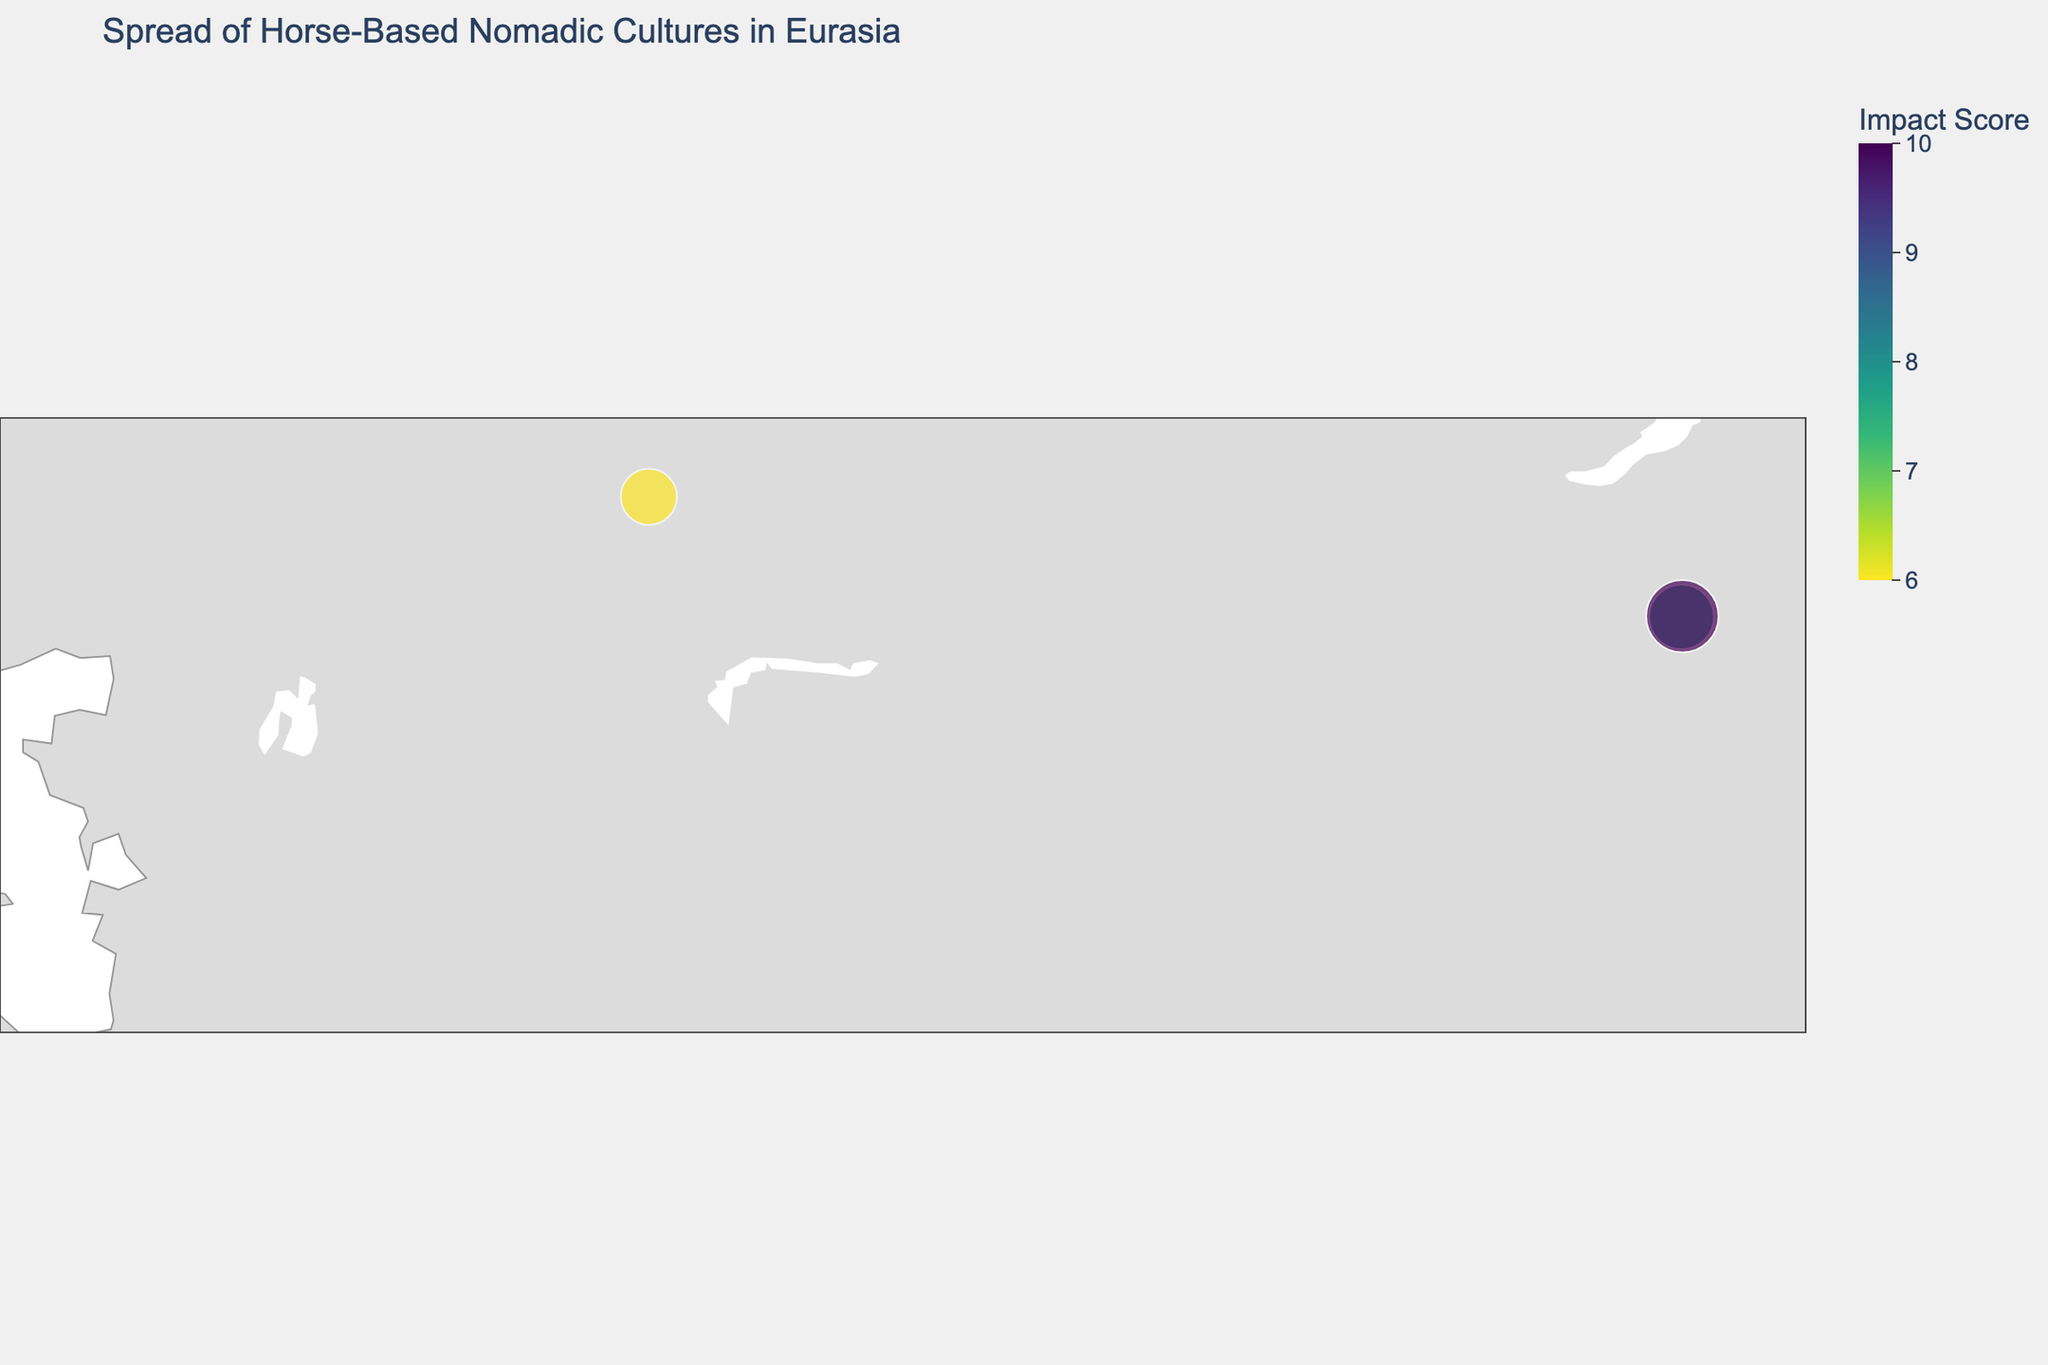Is the plot centered around a specific geographic area? If so, which area? The plot is centered on the Eurasian continent, specifically around the region encompassing the latitude of 45 and longitude of 80. This central positioning ensures that the majority of the horse-based nomadic cultures are appropriately plotted.
Answer: Eurasian continent What is the culture with the highest impact score? Identify the culture with the largest size marker on the map; the largest marker denotes the highest impact score.
Answer: Mongols Do the Huns and Mongols share a similar geographic location? Both the Huns and Mongols are plotted around the latitude of 47.90-47.92 and longitude of 106.88-106.91, indicating that they occupied nearby regions geographically.
Answer: Yes Which cultures had an impact score of 7? By checking the legend and the size of the markers, the cultures with an impact score of 7 are identified. These are Xiongnu, Parthians, and Magyars.
Answer: Xiongnu, Parthians, Magyars How does the color of the markers represent the impact score? The color of the markers follows a sequential Viridis colorscale, where the intensity of the color changes based on the impact score. Higher scores are represented by more intense colors.
Answer: Higher impact score → More intense color What time period did the Kipchaks occupy Eurasia? By examining the hover data linked with the Kipchaks' marker on the map, the time period of the Kipchaks is noted.
Answer: 1000 CE - 1300 CE How many different cultures are represented in the plot? By counting the number of different markers on the plot, the distinct cultures displayed are totaled.
Answer: 10 What is the average impact score of all represented cultures? Sum up the impact scores of all cultures and then divide by the number of cultures: (9+8+10+7+6+7+8+6+7+6) / 10 = 74 / 10 = 7.4
Answer: 7.4 Which culture had the longest time period of influence? By comparing the time periods provided on the hover data for each culture, the one with the longest time span is determined. The Scythians had influence from 800 BCE to 200 CE, totaling around 1000 years.
Answer: Scythians 